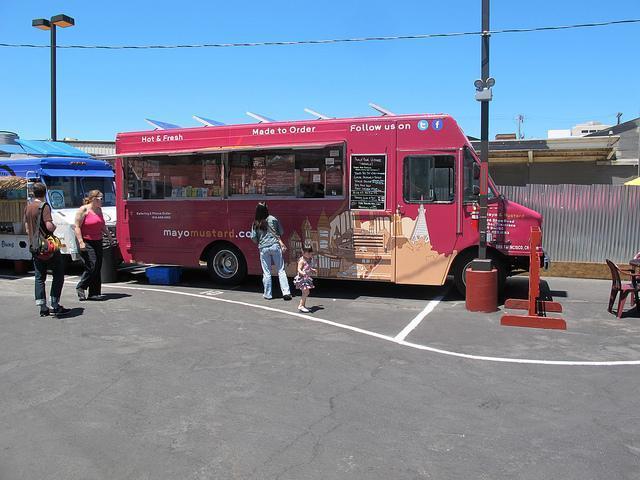How many buses can be seen?
Give a very brief answer. 2. How many trucks are there?
Give a very brief answer. 2. How many people can be seen?
Give a very brief answer. 3. How many umbrellas are in this picture with the train?
Give a very brief answer. 0. 